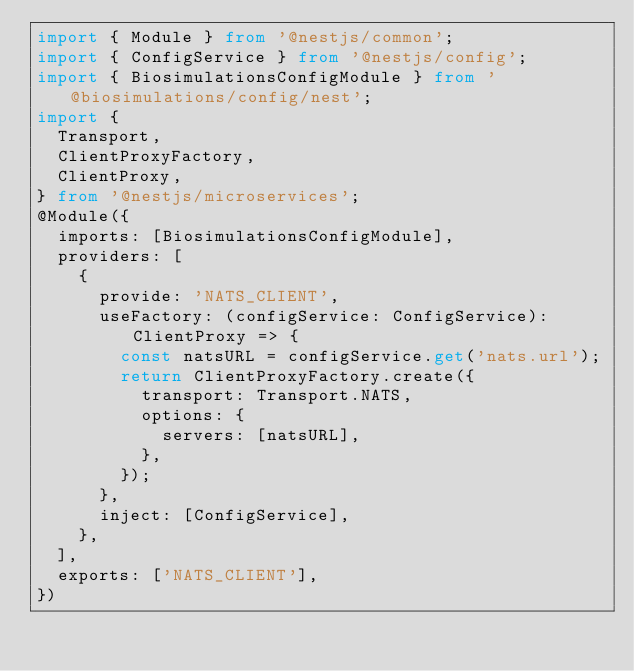<code> <loc_0><loc_0><loc_500><loc_500><_TypeScript_>import { Module } from '@nestjs/common';
import { ConfigService } from '@nestjs/config';
import { BiosimulationsConfigModule } from '@biosimulations/config/nest';
import {
  Transport,
  ClientProxyFactory,
  ClientProxy,
} from '@nestjs/microservices';
@Module({
  imports: [BiosimulationsConfigModule],
  providers: [
    {
      provide: 'NATS_CLIENT',
      useFactory: (configService: ConfigService): ClientProxy => {
        const natsURL = configService.get('nats.url');
        return ClientProxyFactory.create({
          transport: Transport.NATS,
          options: {
            servers: [natsURL],
          },
        });
      },
      inject: [ConfigService],
    },
  ],
  exports: ['NATS_CLIENT'],
})</code> 